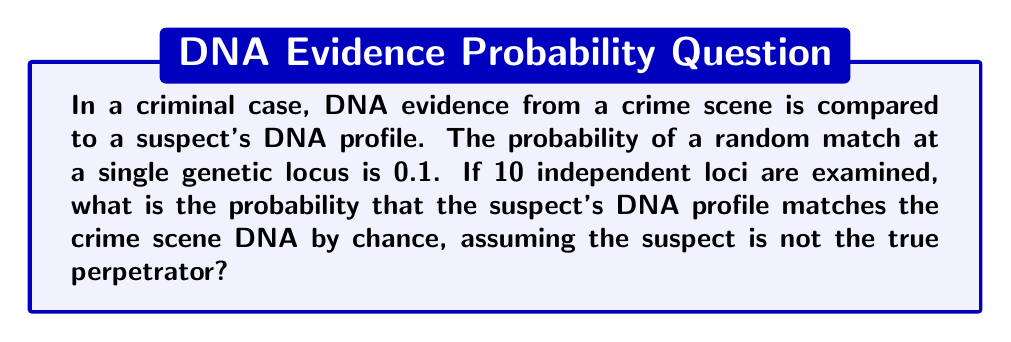Give your solution to this math problem. To solve this problem, we need to understand the concept of independent events and how to calculate their combined probability.

1) Each locus is considered an independent event, with a probability of 0.1 for a random match.

2) We want to calculate the probability of all 10 loci matching by chance. Since these are independent events, we multiply the individual probabilities.

3) The probability of all 10 loci matching is:

   $$P(\text{all 10 loci match}) = 0.1 \times 0.1 \times ... \times 0.1$$ (10 times)

4) This can be written as:

   $$P(\text{all 10 loci match}) = (0.1)^{10}$$

5) Calculate this value:

   $$(0.1)^{10} = 1 \times 10^{-10} = 0.0000000001$$

6) Convert to scientific notation:

   $$1 \times 10^{-10}$$

This extremely low probability indicates that it's very unlikely for a random person's DNA to match the crime scene DNA at all 10 loci by chance, making DNA evidence a powerful tool in forensic identification.
Answer: $1 \times 10^{-10}$ or 0.0000000001 